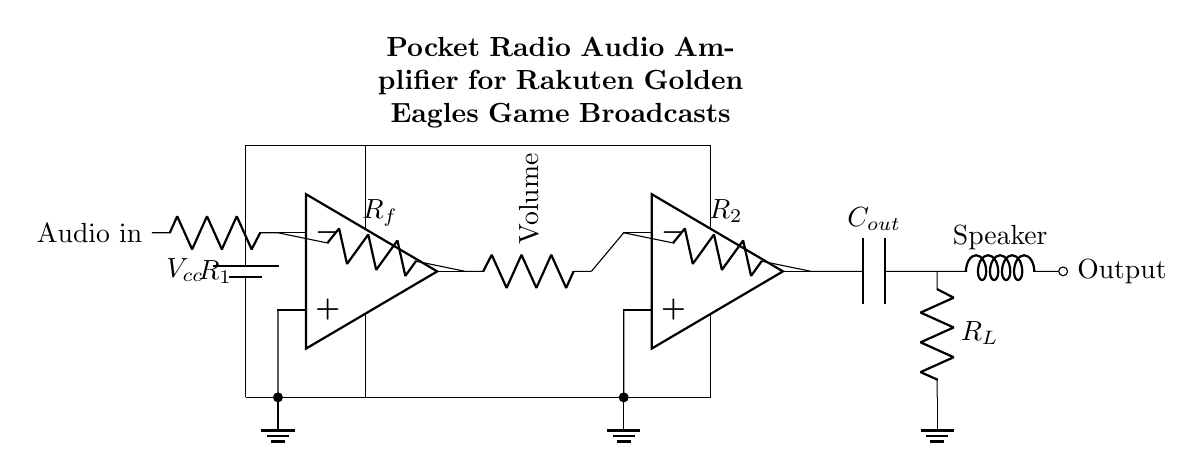what type of amplifiers are used in this circuit? The circuit uses two operational amplifiers, as indicated by the op amp symbols. Each op amp amplifies the audio signal in different stages, providing better sound quality and control.
Answer: operational amplifiers what is the purpose of the component labeled "Volume"? The volume component, typically a potentiometer, adjusts the gain of the amplifier circuit, allowing the user to control output loudness by varying the resistance in the signal path.
Answer: adjust output loudness how many resistors are in the circuit? There are three resistors labeled in the circuit: R1, R2, and Rf, which play significant roles in setting the gain and feedback of the operational amplifiers.
Answer: three resistors what is the role of the capacitor labeled C_out? The capacitor C_out is used to block any DC component from the audio signal while allowing AC signals (the audio) to pass through to the load, which helps in protecting the speaker.
Answer: block DC component which component connects the amplifier to the speaker? The component connecting the amplifier to the speaker is labeled Output, which indicates the final stage where the audio signal is delivered to drive the speaker.
Answer: Output if R1 is 1k ohm and R2 is 2k ohm, what can be inferred about the gain of the first amplifier stage? The gain of the first amplifier stage can be estimated using the formula Gain = Rf/R1. Since Rf is not specified but knowing R1 is 1k ohm suggests that it will determine the amplification level along with Rf. Specific gain cannot be determined without knowing Rf.
Answer: depends on Rf what is the overall function of this circuit? The overall function of the circuit is to amplify audio signals from a radio, making them suitable for driving a small speaker, specifically for listening to game broadcasts clearly.
Answer: amplify audio signals 